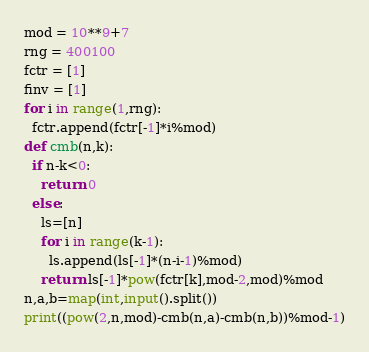Convert code to text. <code><loc_0><loc_0><loc_500><loc_500><_Python_>mod = 10**9+7
rng = 400100
fctr = [1]
finv = [1]
for i in range(1,rng):
  fctr.append(fctr[-1]*i%mod)
def cmb(n,k):
  if n-k<0:
    return 0
  else:
    ls=[n]
    for i in range(k-1):
      ls.append(ls[-1]*(n-i-1)%mod)
    return ls[-1]*pow(fctr[k],mod-2,mod)%mod
n,a,b=map(int,input().split())
print((pow(2,n,mod)-cmb(n,a)-cmb(n,b))%mod-1)</code> 